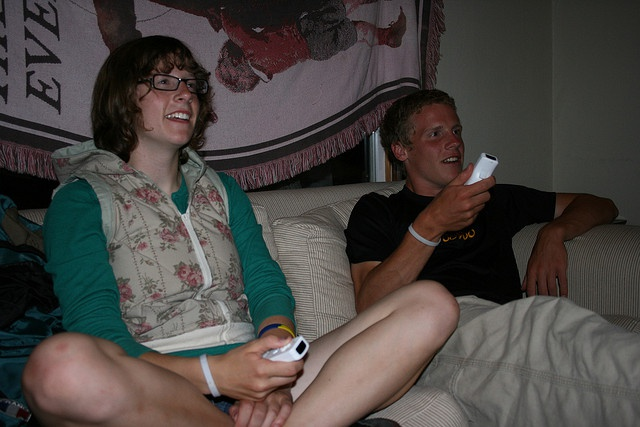Describe the objects in this image and their specific colors. I can see people in black, gray, and darkgray tones, people in black, gray, and maroon tones, couch in black and gray tones, remote in black, lightgray, darkgray, and gray tones, and remote in black, darkgray, and gray tones in this image. 